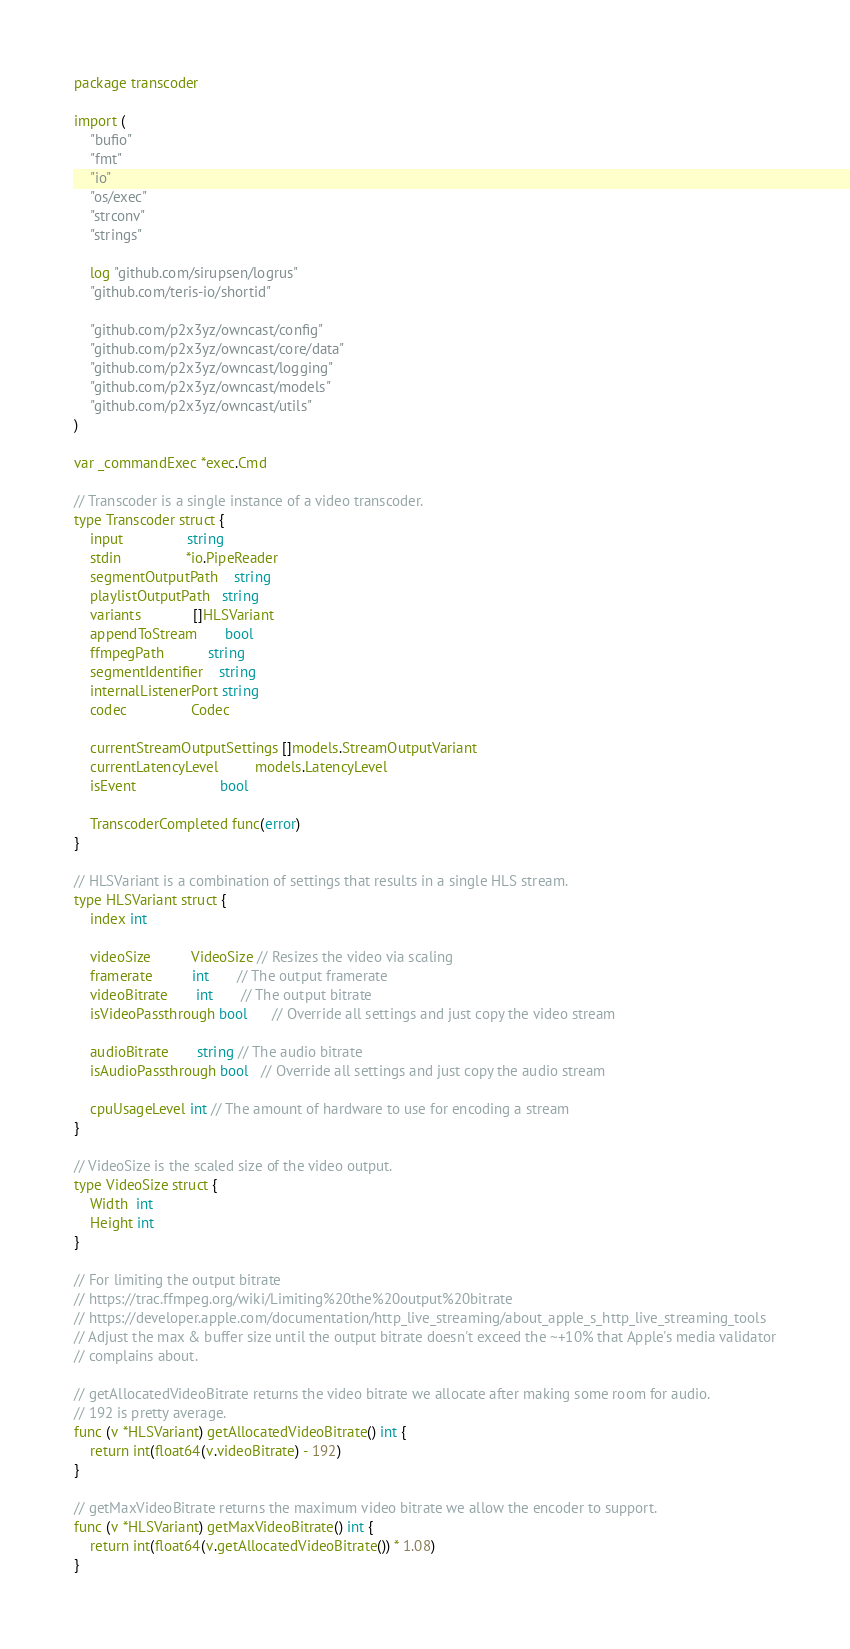<code> <loc_0><loc_0><loc_500><loc_500><_Go_>package transcoder

import (
	"bufio"
	"fmt"
	"io"
	"os/exec"
	"strconv"
	"strings"

	log "github.com/sirupsen/logrus"
	"github.com/teris-io/shortid"

	"github.com/p2x3yz/owncast/config"
	"github.com/p2x3yz/owncast/core/data"
	"github.com/p2x3yz/owncast/logging"
	"github.com/p2x3yz/owncast/models"
	"github.com/p2x3yz/owncast/utils"
)

var _commandExec *exec.Cmd

// Transcoder is a single instance of a video transcoder.
type Transcoder struct {
	input                string
	stdin                *io.PipeReader
	segmentOutputPath    string
	playlistOutputPath   string
	variants             []HLSVariant
	appendToStream       bool
	ffmpegPath           string
	segmentIdentifier    string
	internalListenerPort string
	codec                Codec

	currentStreamOutputSettings []models.StreamOutputVariant
	currentLatencyLevel         models.LatencyLevel
	isEvent                     bool

	TranscoderCompleted func(error)
}

// HLSVariant is a combination of settings that results in a single HLS stream.
type HLSVariant struct {
	index int

	videoSize          VideoSize // Resizes the video via scaling
	framerate          int       // The output framerate
	videoBitrate       int       // The output bitrate
	isVideoPassthrough bool      // Override all settings and just copy the video stream

	audioBitrate       string // The audio bitrate
	isAudioPassthrough bool   // Override all settings and just copy the audio stream

	cpuUsageLevel int // The amount of hardware to use for encoding a stream
}

// VideoSize is the scaled size of the video output.
type VideoSize struct {
	Width  int
	Height int
}

// For limiting the output bitrate
// https://trac.ffmpeg.org/wiki/Limiting%20the%20output%20bitrate
// https://developer.apple.com/documentation/http_live_streaming/about_apple_s_http_live_streaming_tools
// Adjust the max & buffer size until the output bitrate doesn't exceed the ~+10% that Apple's media validator
// complains about.

// getAllocatedVideoBitrate returns the video bitrate we allocate after making some room for audio.
// 192 is pretty average.
func (v *HLSVariant) getAllocatedVideoBitrate() int {
	return int(float64(v.videoBitrate) - 192)
}

// getMaxVideoBitrate returns the maximum video bitrate we allow the encoder to support.
func (v *HLSVariant) getMaxVideoBitrate() int {
	return int(float64(v.getAllocatedVideoBitrate()) * 1.08)
}
</code> 